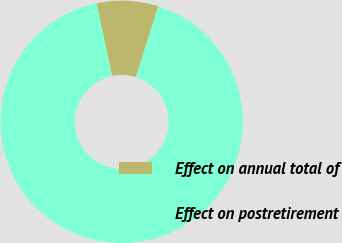Convert chart. <chart><loc_0><loc_0><loc_500><loc_500><pie_chart><fcel>Effect on annual total of<fcel>Effect on postretirement<nl><fcel>8.2%<fcel>91.8%<nl></chart> 